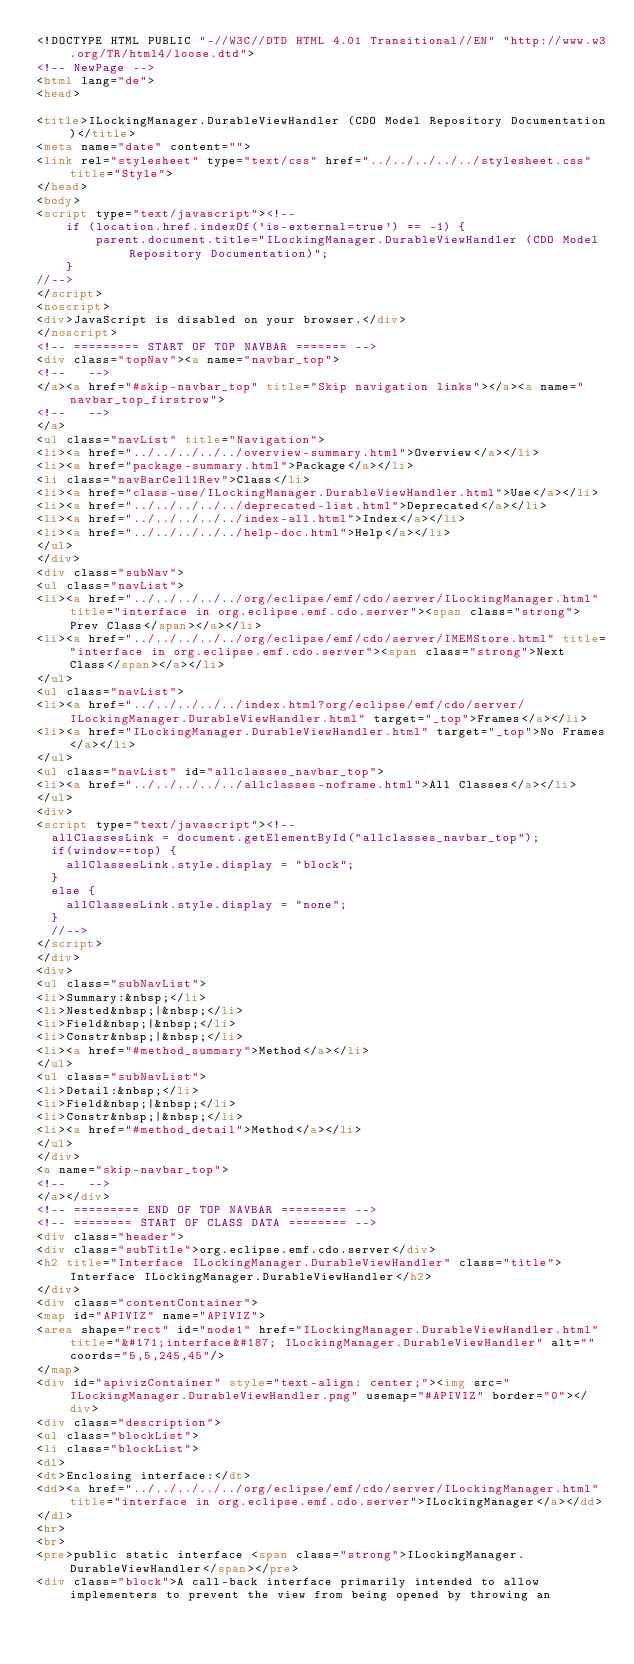<code> <loc_0><loc_0><loc_500><loc_500><_HTML_><!DOCTYPE HTML PUBLIC "-//W3C//DTD HTML 4.01 Transitional//EN" "http://www.w3.org/TR/html4/loose.dtd">
<!-- NewPage -->
<html lang="de">
<head>

<title>ILockingManager.DurableViewHandler (CDO Model Repository Documentation)</title>
<meta name="date" content="">
<link rel="stylesheet" type="text/css" href="../../../../../stylesheet.css" title="Style">
</head>
<body>
<script type="text/javascript"><!--
    if (location.href.indexOf('is-external=true') == -1) {
        parent.document.title="ILockingManager.DurableViewHandler (CDO Model Repository Documentation)";
    }
//-->
</script>
<noscript>
<div>JavaScript is disabled on your browser.</div>
</noscript>
<!-- ========= START OF TOP NAVBAR ======= -->
<div class="topNav"><a name="navbar_top">
<!--   -->
</a><a href="#skip-navbar_top" title="Skip navigation links"></a><a name="navbar_top_firstrow">
<!--   -->
</a>
<ul class="navList" title="Navigation">
<li><a href="../../../../../overview-summary.html">Overview</a></li>
<li><a href="package-summary.html">Package</a></li>
<li class="navBarCell1Rev">Class</li>
<li><a href="class-use/ILockingManager.DurableViewHandler.html">Use</a></li>
<li><a href="../../../../../deprecated-list.html">Deprecated</a></li>
<li><a href="../../../../../index-all.html">Index</a></li>
<li><a href="../../../../../help-doc.html">Help</a></li>
</ul>
</div>
<div class="subNav">
<ul class="navList">
<li><a href="../../../../../org/eclipse/emf/cdo/server/ILockingManager.html" title="interface in org.eclipse.emf.cdo.server"><span class="strong">Prev Class</span></a></li>
<li><a href="../../../../../org/eclipse/emf/cdo/server/IMEMStore.html" title="interface in org.eclipse.emf.cdo.server"><span class="strong">Next Class</span></a></li>
</ul>
<ul class="navList">
<li><a href="../../../../../index.html?org/eclipse/emf/cdo/server/ILockingManager.DurableViewHandler.html" target="_top">Frames</a></li>
<li><a href="ILockingManager.DurableViewHandler.html" target="_top">No Frames</a></li>
</ul>
<ul class="navList" id="allclasses_navbar_top">
<li><a href="../../../../../allclasses-noframe.html">All Classes</a></li>
</ul>
<div>
<script type="text/javascript"><!--
  allClassesLink = document.getElementById("allclasses_navbar_top");
  if(window==top) {
    allClassesLink.style.display = "block";
  }
  else {
    allClassesLink.style.display = "none";
  }
  //-->
</script>
</div>
<div>
<ul class="subNavList">
<li>Summary:&nbsp;</li>
<li>Nested&nbsp;|&nbsp;</li>
<li>Field&nbsp;|&nbsp;</li>
<li>Constr&nbsp;|&nbsp;</li>
<li><a href="#method_summary">Method</a></li>
</ul>
<ul class="subNavList">
<li>Detail:&nbsp;</li>
<li>Field&nbsp;|&nbsp;</li>
<li>Constr&nbsp;|&nbsp;</li>
<li><a href="#method_detail">Method</a></li>
</ul>
</div>
<a name="skip-navbar_top">
<!--   -->
</a></div>
<!-- ========= END OF TOP NAVBAR ========= -->
<!-- ======== START OF CLASS DATA ======== -->
<div class="header">
<div class="subTitle">org.eclipse.emf.cdo.server</div>
<h2 title="Interface ILockingManager.DurableViewHandler" class="title">Interface ILockingManager.DurableViewHandler</h2>
</div>
<div class="contentContainer">
<map id="APIVIZ" name="APIVIZ">
<area shape="rect" id="node1" href="ILockingManager.DurableViewHandler.html" title="&#171;interface&#187; ILockingManager.DurableViewHandler" alt="" coords="5,5,245,45"/>
</map>
<div id="apivizContainer" style="text-align: center;"><img src="ILockingManager.DurableViewHandler.png" usemap="#APIVIZ" border="0"></div>
<div class="description">
<ul class="blockList">
<li class="blockList">
<dl>
<dt>Enclosing interface:</dt>
<dd><a href="../../../../../org/eclipse/emf/cdo/server/ILockingManager.html" title="interface in org.eclipse.emf.cdo.server">ILockingManager</a></dd>
</dl>
<hr>
<br>
<pre>public static interface <span class="strong">ILockingManager.DurableViewHandler</span></pre>
<div class="block">A call-back interface primarily intended to allow implementers to prevent the view from being opened by throwing an</code> 